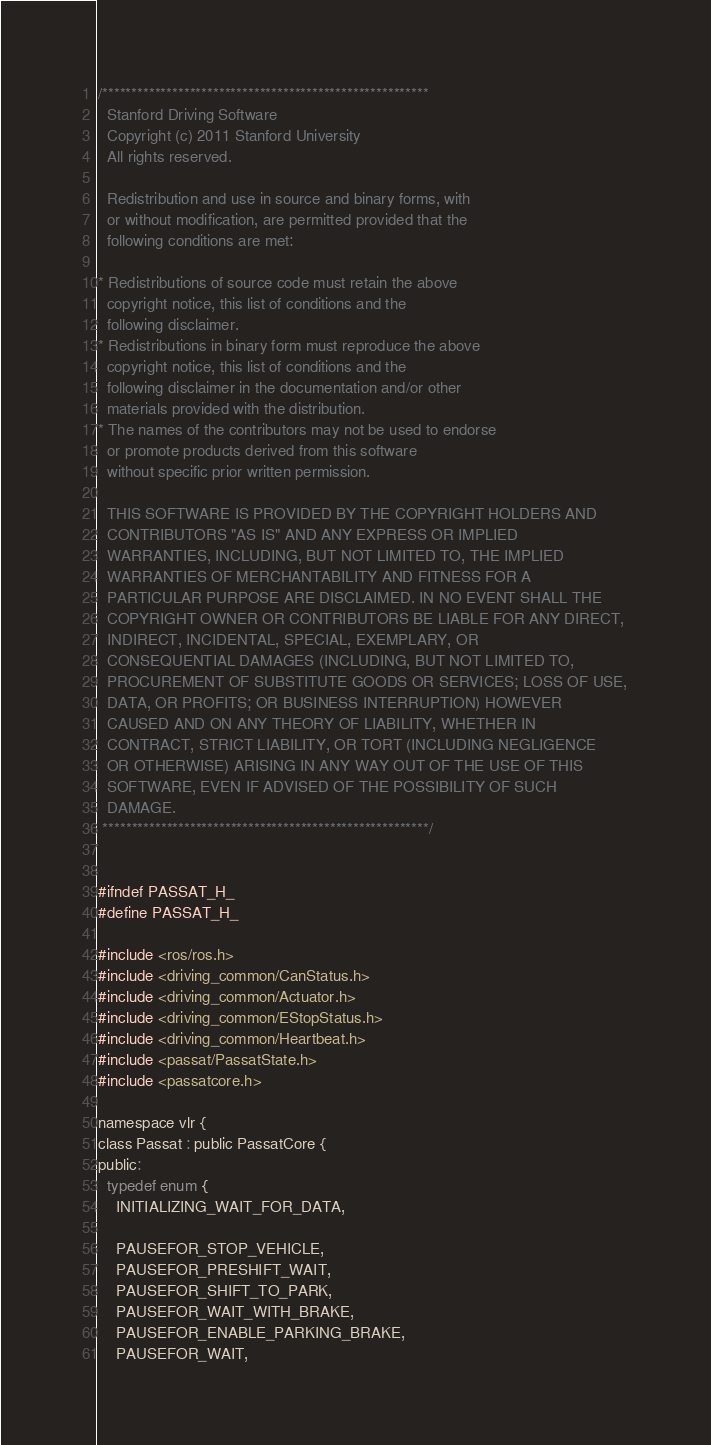Convert code to text. <code><loc_0><loc_0><loc_500><loc_500><_C_>/********************************************************
  Stanford Driving Software
  Copyright (c) 2011 Stanford University
  All rights reserved.

  Redistribution and use in source and binary forms, with 
  or without modification, are permitted provided that the 
  following conditions are met:

* Redistributions of source code must retain the above 
  copyright notice, this list of conditions and the 
  following disclaimer.
* Redistributions in binary form must reproduce the above
  copyright notice, this list of conditions and the 
  following disclaimer in the documentation and/or other
  materials provided with the distribution.
* The names of the contributors may not be used to endorse
  or promote products derived from this software
  without specific prior written permission.

  THIS SOFTWARE IS PROVIDED BY THE COPYRIGHT HOLDERS AND
  CONTRIBUTORS "AS IS" AND ANY EXPRESS OR IMPLIED
  WARRANTIES, INCLUDING, BUT NOT LIMITED TO, THE IMPLIED
  WARRANTIES OF MERCHANTABILITY AND FITNESS FOR A
  PARTICULAR PURPOSE ARE DISCLAIMED. IN NO EVENT SHALL THE
  COPYRIGHT OWNER OR CONTRIBUTORS BE LIABLE FOR ANY DIRECT, 
  INDIRECT, INCIDENTAL, SPECIAL, EXEMPLARY, OR 
  CONSEQUENTIAL DAMAGES (INCLUDING, BUT NOT LIMITED TO, 
  PROCUREMENT OF SUBSTITUTE GOODS OR SERVICES; LOSS OF USE,
  DATA, OR PROFITS; OR BUSINESS INTERRUPTION) HOWEVER
  CAUSED AND ON ANY THEORY OF LIABILITY, WHETHER IN 
  CONTRACT, STRICT LIABILITY, OR TORT (INCLUDING NEGLIGENCE 
  OR OTHERWISE) ARISING IN ANY WAY OUT OF THE USE OF THIS
  SOFTWARE, EVEN IF ADVISED OF THE POSSIBILITY OF SUCH
  DAMAGE.
 ********************************************************/


#ifndef PASSAT_H_
#define PASSAT_H_

#include <ros/ros.h>
#include <driving_common/CanStatus.h>
#include <driving_common/Actuator.h>
#include <driving_common/EStopStatus.h>
#include <driving_common/Heartbeat.h>
#include <passat/PassatState.h>
#include <passatcore.h>

namespace vlr {
class Passat : public PassatCore {
public:
  typedef enum {
    INITIALIZING_WAIT_FOR_DATA,

    PAUSEFOR_STOP_VEHICLE,
    PAUSEFOR_PRESHIFT_WAIT,
    PAUSEFOR_SHIFT_TO_PARK,
    PAUSEFOR_WAIT_WITH_BRAKE,
    PAUSEFOR_ENABLE_PARKING_BRAKE,
    PAUSEFOR_WAIT,</code> 